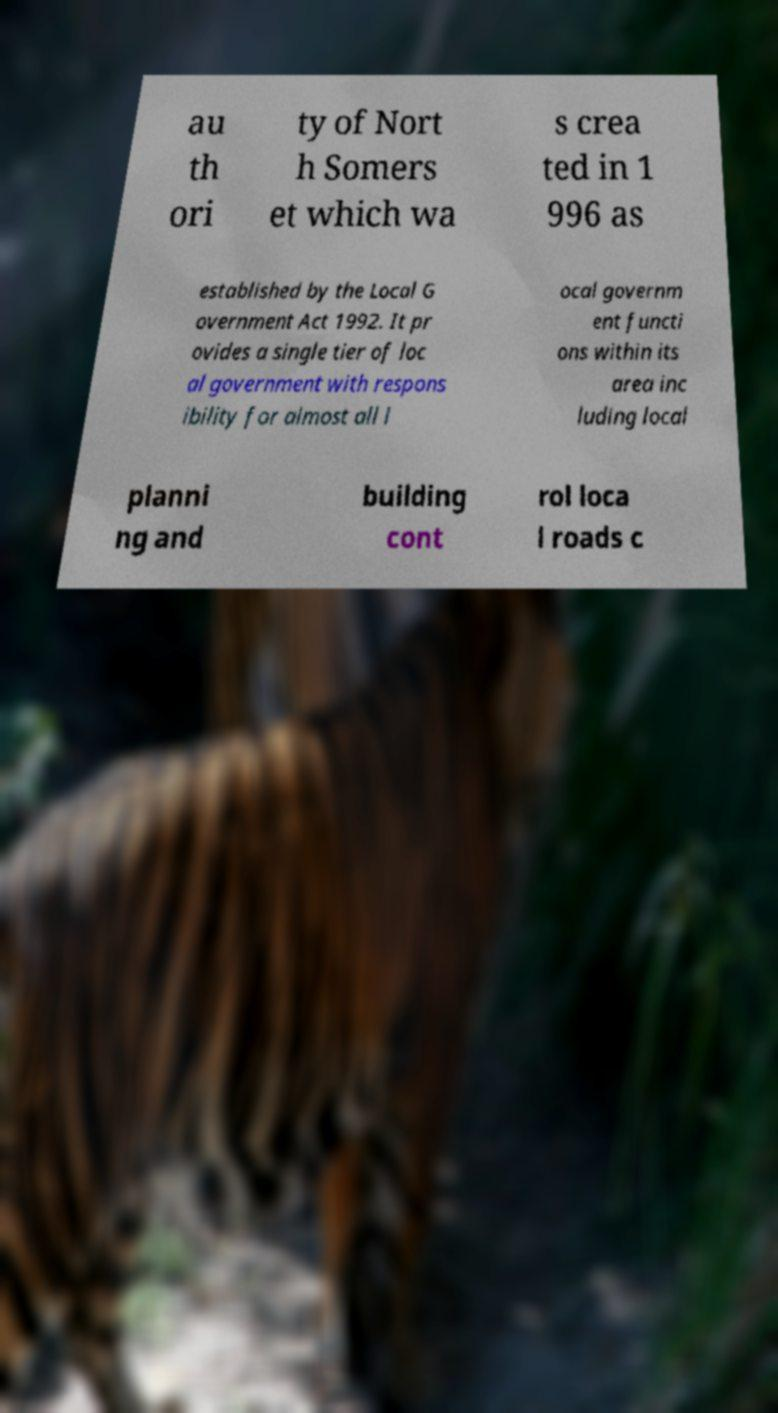Can you accurately transcribe the text from the provided image for me? au th ori ty of Nort h Somers et which wa s crea ted in 1 996 as established by the Local G overnment Act 1992. It pr ovides a single tier of loc al government with respons ibility for almost all l ocal governm ent functi ons within its area inc luding local planni ng and building cont rol loca l roads c 